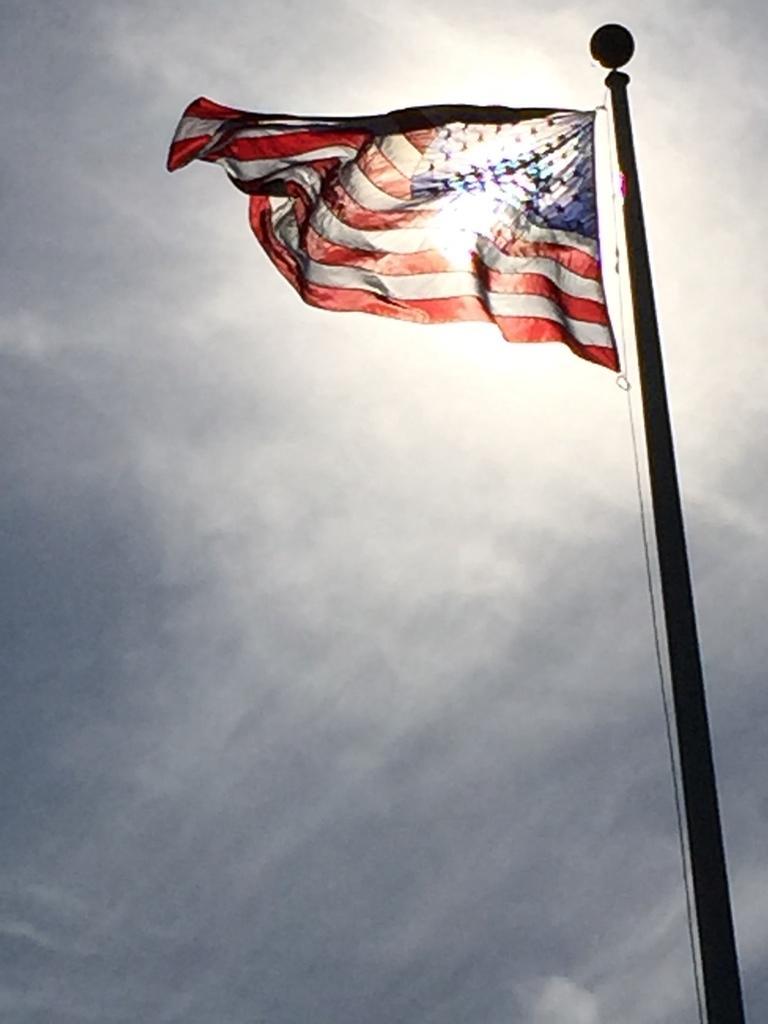Describe this image in one or two sentences. In this image I can see the flag to the pole. I can see the flag is in red, white and blue color. In the background I can see the clouds and the sky. 